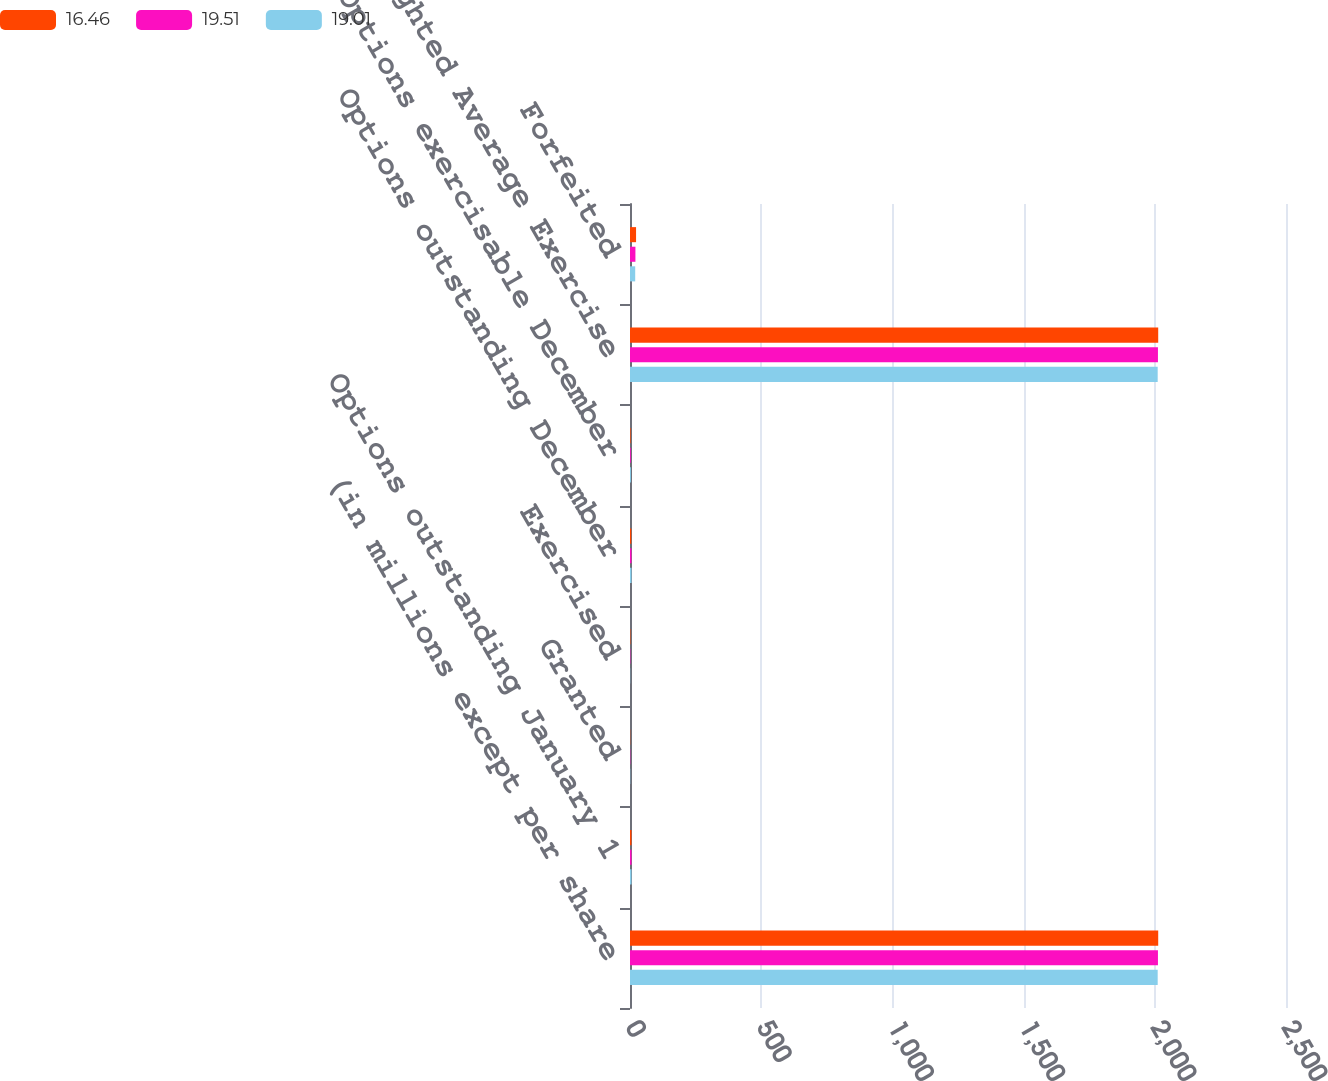<chart> <loc_0><loc_0><loc_500><loc_500><stacked_bar_chart><ecel><fcel>(in millions except per share<fcel>Options outstanding January 1<fcel>Granted<fcel>Exercised<fcel>Options outstanding December<fcel>Options exercisable December<fcel>Weighted Average Exercise<fcel>Forfeited<nl><fcel>16.46<fcel>2013<fcel>5.6<fcel>0.9<fcel>1.6<fcel>4.8<fcel>2.3<fcel>2013<fcel>23.1<nl><fcel>19.51<fcel>2012<fcel>5.8<fcel>1.2<fcel>1.4<fcel>5.6<fcel>3<fcel>2012<fcel>20.66<nl><fcel>19.01<fcel>2011<fcel>5.7<fcel>1<fcel>0.8<fcel>5.8<fcel>3.5<fcel>2011<fcel>19.84<nl></chart> 